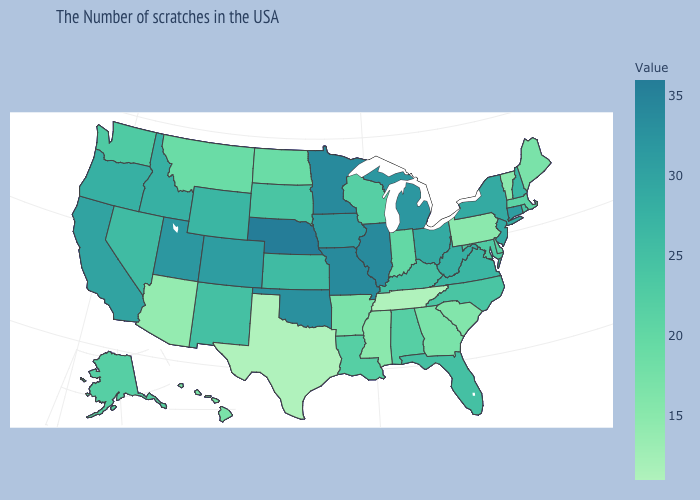Does the map have missing data?
Short answer required. No. Does the map have missing data?
Be succinct. No. Which states have the highest value in the USA?
Quick response, please. Nebraska. Does the map have missing data?
Write a very short answer. No. Which states have the highest value in the USA?
Give a very brief answer. Nebraska. 